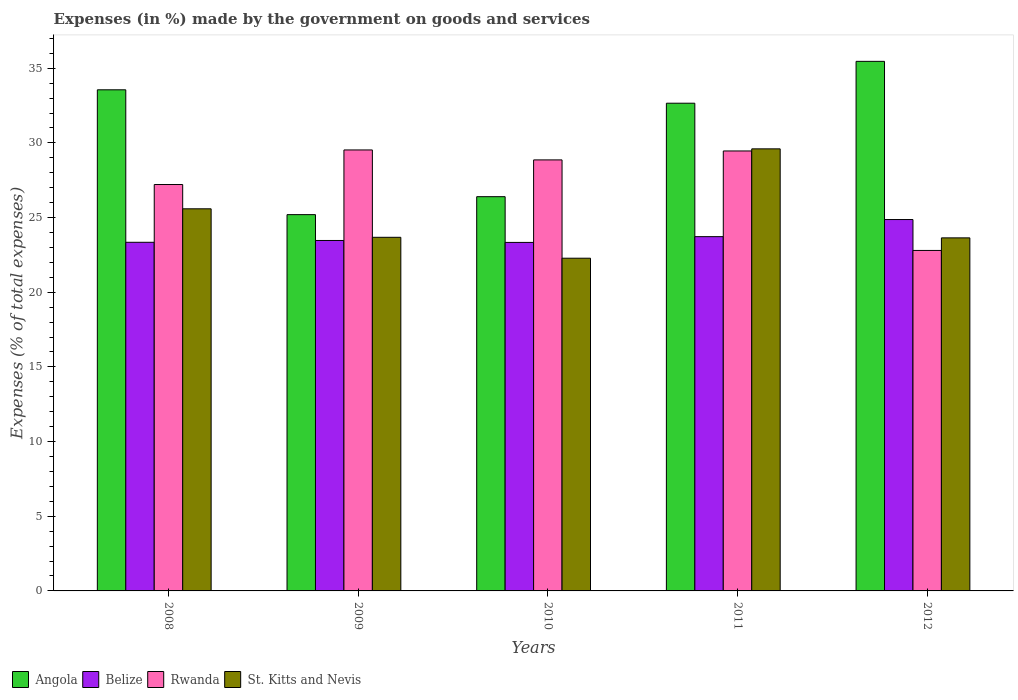How many different coloured bars are there?
Your response must be concise. 4. Are the number of bars on each tick of the X-axis equal?
Ensure brevity in your answer.  Yes. What is the label of the 1st group of bars from the left?
Ensure brevity in your answer.  2008. In how many cases, is the number of bars for a given year not equal to the number of legend labels?
Give a very brief answer. 0. What is the percentage of expenses made by the government on goods and services in Rwanda in 2010?
Your response must be concise. 28.86. Across all years, what is the maximum percentage of expenses made by the government on goods and services in Angola?
Your answer should be very brief. 35.46. Across all years, what is the minimum percentage of expenses made by the government on goods and services in Rwanda?
Offer a terse response. 22.8. What is the total percentage of expenses made by the government on goods and services in Rwanda in the graph?
Your answer should be compact. 137.86. What is the difference between the percentage of expenses made by the government on goods and services in St. Kitts and Nevis in 2009 and that in 2011?
Your response must be concise. -5.92. What is the difference between the percentage of expenses made by the government on goods and services in Angola in 2008 and the percentage of expenses made by the government on goods and services in Belize in 2012?
Your response must be concise. 8.69. What is the average percentage of expenses made by the government on goods and services in Rwanda per year?
Make the answer very short. 27.57. In the year 2010, what is the difference between the percentage of expenses made by the government on goods and services in Rwanda and percentage of expenses made by the government on goods and services in Angola?
Give a very brief answer. 2.46. What is the ratio of the percentage of expenses made by the government on goods and services in Angola in 2011 to that in 2012?
Ensure brevity in your answer.  0.92. Is the difference between the percentage of expenses made by the government on goods and services in Rwanda in 2011 and 2012 greater than the difference between the percentage of expenses made by the government on goods and services in Angola in 2011 and 2012?
Make the answer very short. Yes. What is the difference between the highest and the second highest percentage of expenses made by the government on goods and services in Belize?
Provide a succinct answer. 1.15. What is the difference between the highest and the lowest percentage of expenses made by the government on goods and services in St. Kitts and Nevis?
Provide a short and direct response. 7.32. Is the sum of the percentage of expenses made by the government on goods and services in Rwanda in 2008 and 2012 greater than the maximum percentage of expenses made by the government on goods and services in Belize across all years?
Give a very brief answer. Yes. Is it the case that in every year, the sum of the percentage of expenses made by the government on goods and services in Belize and percentage of expenses made by the government on goods and services in Rwanda is greater than the sum of percentage of expenses made by the government on goods and services in St. Kitts and Nevis and percentage of expenses made by the government on goods and services in Angola?
Keep it short and to the point. No. What does the 3rd bar from the left in 2012 represents?
Make the answer very short. Rwanda. What does the 2nd bar from the right in 2008 represents?
Make the answer very short. Rwanda. Is it the case that in every year, the sum of the percentage of expenses made by the government on goods and services in Angola and percentage of expenses made by the government on goods and services in Rwanda is greater than the percentage of expenses made by the government on goods and services in Belize?
Offer a terse response. Yes. Are all the bars in the graph horizontal?
Give a very brief answer. No. Where does the legend appear in the graph?
Give a very brief answer. Bottom left. How are the legend labels stacked?
Your answer should be very brief. Horizontal. What is the title of the graph?
Offer a very short reply. Expenses (in %) made by the government on goods and services. Does "Bosnia and Herzegovina" appear as one of the legend labels in the graph?
Provide a succinct answer. No. What is the label or title of the X-axis?
Provide a succinct answer. Years. What is the label or title of the Y-axis?
Make the answer very short. Expenses (% of total expenses). What is the Expenses (% of total expenses) in Angola in 2008?
Offer a very short reply. 33.56. What is the Expenses (% of total expenses) in Belize in 2008?
Your answer should be compact. 23.35. What is the Expenses (% of total expenses) of Rwanda in 2008?
Your response must be concise. 27.21. What is the Expenses (% of total expenses) in St. Kitts and Nevis in 2008?
Make the answer very short. 25.59. What is the Expenses (% of total expenses) in Angola in 2009?
Your response must be concise. 25.2. What is the Expenses (% of total expenses) of Belize in 2009?
Offer a terse response. 23.47. What is the Expenses (% of total expenses) in Rwanda in 2009?
Your response must be concise. 29.53. What is the Expenses (% of total expenses) in St. Kitts and Nevis in 2009?
Your answer should be very brief. 23.68. What is the Expenses (% of total expenses) of Angola in 2010?
Provide a short and direct response. 26.4. What is the Expenses (% of total expenses) in Belize in 2010?
Offer a very short reply. 23.34. What is the Expenses (% of total expenses) of Rwanda in 2010?
Offer a very short reply. 28.86. What is the Expenses (% of total expenses) in St. Kitts and Nevis in 2010?
Provide a succinct answer. 22.28. What is the Expenses (% of total expenses) in Angola in 2011?
Provide a succinct answer. 32.66. What is the Expenses (% of total expenses) of Belize in 2011?
Your response must be concise. 23.72. What is the Expenses (% of total expenses) in Rwanda in 2011?
Keep it short and to the point. 29.46. What is the Expenses (% of total expenses) in St. Kitts and Nevis in 2011?
Keep it short and to the point. 29.6. What is the Expenses (% of total expenses) in Angola in 2012?
Your response must be concise. 35.46. What is the Expenses (% of total expenses) of Belize in 2012?
Offer a very short reply. 24.87. What is the Expenses (% of total expenses) of Rwanda in 2012?
Offer a terse response. 22.8. What is the Expenses (% of total expenses) in St. Kitts and Nevis in 2012?
Make the answer very short. 23.64. Across all years, what is the maximum Expenses (% of total expenses) of Angola?
Provide a succinct answer. 35.46. Across all years, what is the maximum Expenses (% of total expenses) in Belize?
Your answer should be compact. 24.87. Across all years, what is the maximum Expenses (% of total expenses) of Rwanda?
Make the answer very short. 29.53. Across all years, what is the maximum Expenses (% of total expenses) in St. Kitts and Nevis?
Make the answer very short. 29.6. Across all years, what is the minimum Expenses (% of total expenses) of Angola?
Ensure brevity in your answer.  25.2. Across all years, what is the minimum Expenses (% of total expenses) of Belize?
Keep it short and to the point. 23.34. Across all years, what is the minimum Expenses (% of total expenses) of Rwanda?
Offer a very short reply. 22.8. Across all years, what is the minimum Expenses (% of total expenses) of St. Kitts and Nevis?
Keep it short and to the point. 22.28. What is the total Expenses (% of total expenses) of Angola in the graph?
Ensure brevity in your answer.  153.27. What is the total Expenses (% of total expenses) in Belize in the graph?
Ensure brevity in your answer.  118.74. What is the total Expenses (% of total expenses) in Rwanda in the graph?
Offer a terse response. 137.86. What is the total Expenses (% of total expenses) of St. Kitts and Nevis in the graph?
Ensure brevity in your answer.  124.79. What is the difference between the Expenses (% of total expenses) in Angola in 2008 and that in 2009?
Provide a short and direct response. 8.36. What is the difference between the Expenses (% of total expenses) in Belize in 2008 and that in 2009?
Provide a short and direct response. -0.12. What is the difference between the Expenses (% of total expenses) in Rwanda in 2008 and that in 2009?
Your response must be concise. -2.32. What is the difference between the Expenses (% of total expenses) of St. Kitts and Nevis in 2008 and that in 2009?
Ensure brevity in your answer.  1.91. What is the difference between the Expenses (% of total expenses) in Angola in 2008 and that in 2010?
Ensure brevity in your answer.  7.16. What is the difference between the Expenses (% of total expenses) in Belize in 2008 and that in 2010?
Provide a short and direct response. 0.01. What is the difference between the Expenses (% of total expenses) of Rwanda in 2008 and that in 2010?
Provide a succinct answer. -1.65. What is the difference between the Expenses (% of total expenses) in St. Kitts and Nevis in 2008 and that in 2010?
Your answer should be compact. 3.31. What is the difference between the Expenses (% of total expenses) of Angola in 2008 and that in 2011?
Keep it short and to the point. 0.9. What is the difference between the Expenses (% of total expenses) of Belize in 2008 and that in 2011?
Offer a very short reply. -0.38. What is the difference between the Expenses (% of total expenses) of Rwanda in 2008 and that in 2011?
Offer a very short reply. -2.25. What is the difference between the Expenses (% of total expenses) of St. Kitts and Nevis in 2008 and that in 2011?
Your answer should be very brief. -4.01. What is the difference between the Expenses (% of total expenses) in Angola in 2008 and that in 2012?
Provide a succinct answer. -1.91. What is the difference between the Expenses (% of total expenses) of Belize in 2008 and that in 2012?
Provide a short and direct response. -1.52. What is the difference between the Expenses (% of total expenses) of Rwanda in 2008 and that in 2012?
Provide a succinct answer. 4.41. What is the difference between the Expenses (% of total expenses) of St. Kitts and Nevis in 2008 and that in 2012?
Offer a very short reply. 1.95. What is the difference between the Expenses (% of total expenses) of Angola in 2009 and that in 2010?
Offer a very short reply. -1.2. What is the difference between the Expenses (% of total expenses) in Belize in 2009 and that in 2010?
Provide a short and direct response. 0.13. What is the difference between the Expenses (% of total expenses) of Rwanda in 2009 and that in 2010?
Provide a succinct answer. 0.67. What is the difference between the Expenses (% of total expenses) in St. Kitts and Nevis in 2009 and that in 2010?
Give a very brief answer. 1.4. What is the difference between the Expenses (% of total expenses) in Angola in 2009 and that in 2011?
Your answer should be compact. -7.46. What is the difference between the Expenses (% of total expenses) of Belize in 2009 and that in 2011?
Keep it short and to the point. -0.26. What is the difference between the Expenses (% of total expenses) in Rwanda in 2009 and that in 2011?
Offer a very short reply. 0.07. What is the difference between the Expenses (% of total expenses) in St. Kitts and Nevis in 2009 and that in 2011?
Provide a succinct answer. -5.92. What is the difference between the Expenses (% of total expenses) of Angola in 2009 and that in 2012?
Keep it short and to the point. -10.26. What is the difference between the Expenses (% of total expenses) of Belize in 2009 and that in 2012?
Give a very brief answer. -1.4. What is the difference between the Expenses (% of total expenses) in Rwanda in 2009 and that in 2012?
Your answer should be compact. 6.73. What is the difference between the Expenses (% of total expenses) in St. Kitts and Nevis in 2009 and that in 2012?
Offer a very short reply. 0.04. What is the difference between the Expenses (% of total expenses) in Angola in 2010 and that in 2011?
Ensure brevity in your answer.  -6.26. What is the difference between the Expenses (% of total expenses) in Belize in 2010 and that in 2011?
Offer a very short reply. -0.39. What is the difference between the Expenses (% of total expenses) in Rwanda in 2010 and that in 2011?
Give a very brief answer. -0.6. What is the difference between the Expenses (% of total expenses) of St. Kitts and Nevis in 2010 and that in 2011?
Make the answer very short. -7.32. What is the difference between the Expenses (% of total expenses) of Angola in 2010 and that in 2012?
Offer a terse response. -9.06. What is the difference between the Expenses (% of total expenses) in Belize in 2010 and that in 2012?
Your response must be concise. -1.53. What is the difference between the Expenses (% of total expenses) in Rwanda in 2010 and that in 2012?
Your response must be concise. 6.06. What is the difference between the Expenses (% of total expenses) in St. Kitts and Nevis in 2010 and that in 2012?
Your answer should be very brief. -1.36. What is the difference between the Expenses (% of total expenses) in Angola in 2011 and that in 2012?
Make the answer very short. -2.8. What is the difference between the Expenses (% of total expenses) of Belize in 2011 and that in 2012?
Provide a short and direct response. -1.15. What is the difference between the Expenses (% of total expenses) in Rwanda in 2011 and that in 2012?
Give a very brief answer. 6.66. What is the difference between the Expenses (% of total expenses) in St. Kitts and Nevis in 2011 and that in 2012?
Keep it short and to the point. 5.96. What is the difference between the Expenses (% of total expenses) in Angola in 2008 and the Expenses (% of total expenses) in Belize in 2009?
Offer a terse response. 10.09. What is the difference between the Expenses (% of total expenses) in Angola in 2008 and the Expenses (% of total expenses) in Rwanda in 2009?
Ensure brevity in your answer.  4.03. What is the difference between the Expenses (% of total expenses) of Angola in 2008 and the Expenses (% of total expenses) of St. Kitts and Nevis in 2009?
Give a very brief answer. 9.88. What is the difference between the Expenses (% of total expenses) of Belize in 2008 and the Expenses (% of total expenses) of Rwanda in 2009?
Ensure brevity in your answer.  -6.18. What is the difference between the Expenses (% of total expenses) of Belize in 2008 and the Expenses (% of total expenses) of St. Kitts and Nevis in 2009?
Offer a terse response. -0.33. What is the difference between the Expenses (% of total expenses) in Rwanda in 2008 and the Expenses (% of total expenses) in St. Kitts and Nevis in 2009?
Your response must be concise. 3.53. What is the difference between the Expenses (% of total expenses) of Angola in 2008 and the Expenses (% of total expenses) of Belize in 2010?
Ensure brevity in your answer.  10.22. What is the difference between the Expenses (% of total expenses) in Angola in 2008 and the Expenses (% of total expenses) in Rwanda in 2010?
Your answer should be compact. 4.69. What is the difference between the Expenses (% of total expenses) of Angola in 2008 and the Expenses (% of total expenses) of St. Kitts and Nevis in 2010?
Ensure brevity in your answer.  11.28. What is the difference between the Expenses (% of total expenses) in Belize in 2008 and the Expenses (% of total expenses) in Rwanda in 2010?
Ensure brevity in your answer.  -5.52. What is the difference between the Expenses (% of total expenses) of Belize in 2008 and the Expenses (% of total expenses) of St. Kitts and Nevis in 2010?
Your response must be concise. 1.07. What is the difference between the Expenses (% of total expenses) of Rwanda in 2008 and the Expenses (% of total expenses) of St. Kitts and Nevis in 2010?
Keep it short and to the point. 4.93. What is the difference between the Expenses (% of total expenses) of Angola in 2008 and the Expenses (% of total expenses) of Belize in 2011?
Offer a very short reply. 9.83. What is the difference between the Expenses (% of total expenses) in Angola in 2008 and the Expenses (% of total expenses) in Rwanda in 2011?
Offer a very short reply. 4.09. What is the difference between the Expenses (% of total expenses) in Angola in 2008 and the Expenses (% of total expenses) in St. Kitts and Nevis in 2011?
Ensure brevity in your answer.  3.95. What is the difference between the Expenses (% of total expenses) of Belize in 2008 and the Expenses (% of total expenses) of Rwanda in 2011?
Offer a very short reply. -6.12. What is the difference between the Expenses (% of total expenses) of Belize in 2008 and the Expenses (% of total expenses) of St. Kitts and Nevis in 2011?
Your answer should be compact. -6.26. What is the difference between the Expenses (% of total expenses) of Rwanda in 2008 and the Expenses (% of total expenses) of St. Kitts and Nevis in 2011?
Make the answer very short. -2.39. What is the difference between the Expenses (% of total expenses) in Angola in 2008 and the Expenses (% of total expenses) in Belize in 2012?
Your response must be concise. 8.69. What is the difference between the Expenses (% of total expenses) in Angola in 2008 and the Expenses (% of total expenses) in Rwanda in 2012?
Your answer should be compact. 10.76. What is the difference between the Expenses (% of total expenses) in Angola in 2008 and the Expenses (% of total expenses) in St. Kitts and Nevis in 2012?
Your answer should be compact. 9.91. What is the difference between the Expenses (% of total expenses) in Belize in 2008 and the Expenses (% of total expenses) in Rwanda in 2012?
Offer a very short reply. 0.55. What is the difference between the Expenses (% of total expenses) of Belize in 2008 and the Expenses (% of total expenses) of St. Kitts and Nevis in 2012?
Your answer should be very brief. -0.3. What is the difference between the Expenses (% of total expenses) in Rwanda in 2008 and the Expenses (% of total expenses) in St. Kitts and Nevis in 2012?
Your answer should be very brief. 3.57. What is the difference between the Expenses (% of total expenses) of Angola in 2009 and the Expenses (% of total expenses) of Belize in 2010?
Keep it short and to the point. 1.86. What is the difference between the Expenses (% of total expenses) in Angola in 2009 and the Expenses (% of total expenses) in Rwanda in 2010?
Your response must be concise. -3.67. What is the difference between the Expenses (% of total expenses) of Angola in 2009 and the Expenses (% of total expenses) of St. Kitts and Nevis in 2010?
Provide a succinct answer. 2.92. What is the difference between the Expenses (% of total expenses) in Belize in 2009 and the Expenses (% of total expenses) in Rwanda in 2010?
Your answer should be compact. -5.4. What is the difference between the Expenses (% of total expenses) of Belize in 2009 and the Expenses (% of total expenses) of St. Kitts and Nevis in 2010?
Make the answer very short. 1.19. What is the difference between the Expenses (% of total expenses) of Rwanda in 2009 and the Expenses (% of total expenses) of St. Kitts and Nevis in 2010?
Give a very brief answer. 7.25. What is the difference between the Expenses (% of total expenses) of Angola in 2009 and the Expenses (% of total expenses) of Belize in 2011?
Give a very brief answer. 1.47. What is the difference between the Expenses (% of total expenses) in Angola in 2009 and the Expenses (% of total expenses) in Rwanda in 2011?
Your answer should be compact. -4.26. What is the difference between the Expenses (% of total expenses) in Angola in 2009 and the Expenses (% of total expenses) in St. Kitts and Nevis in 2011?
Ensure brevity in your answer.  -4.41. What is the difference between the Expenses (% of total expenses) in Belize in 2009 and the Expenses (% of total expenses) in Rwanda in 2011?
Keep it short and to the point. -5.99. What is the difference between the Expenses (% of total expenses) in Belize in 2009 and the Expenses (% of total expenses) in St. Kitts and Nevis in 2011?
Make the answer very short. -6.13. What is the difference between the Expenses (% of total expenses) of Rwanda in 2009 and the Expenses (% of total expenses) of St. Kitts and Nevis in 2011?
Make the answer very short. -0.07. What is the difference between the Expenses (% of total expenses) of Angola in 2009 and the Expenses (% of total expenses) of Belize in 2012?
Ensure brevity in your answer.  0.33. What is the difference between the Expenses (% of total expenses) in Angola in 2009 and the Expenses (% of total expenses) in Rwanda in 2012?
Your answer should be very brief. 2.4. What is the difference between the Expenses (% of total expenses) in Angola in 2009 and the Expenses (% of total expenses) in St. Kitts and Nevis in 2012?
Ensure brevity in your answer.  1.56. What is the difference between the Expenses (% of total expenses) of Belize in 2009 and the Expenses (% of total expenses) of Rwanda in 2012?
Your answer should be very brief. 0.67. What is the difference between the Expenses (% of total expenses) in Belize in 2009 and the Expenses (% of total expenses) in St. Kitts and Nevis in 2012?
Ensure brevity in your answer.  -0.17. What is the difference between the Expenses (% of total expenses) in Rwanda in 2009 and the Expenses (% of total expenses) in St. Kitts and Nevis in 2012?
Offer a very short reply. 5.89. What is the difference between the Expenses (% of total expenses) of Angola in 2010 and the Expenses (% of total expenses) of Belize in 2011?
Your answer should be compact. 2.68. What is the difference between the Expenses (% of total expenses) in Angola in 2010 and the Expenses (% of total expenses) in Rwanda in 2011?
Offer a terse response. -3.06. What is the difference between the Expenses (% of total expenses) in Angola in 2010 and the Expenses (% of total expenses) in St. Kitts and Nevis in 2011?
Your response must be concise. -3.2. What is the difference between the Expenses (% of total expenses) of Belize in 2010 and the Expenses (% of total expenses) of Rwanda in 2011?
Make the answer very short. -6.12. What is the difference between the Expenses (% of total expenses) of Belize in 2010 and the Expenses (% of total expenses) of St. Kitts and Nevis in 2011?
Your response must be concise. -6.27. What is the difference between the Expenses (% of total expenses) of Rwanda in 2010 and the Expenses (% of total expenses) of St. Kitts and Nevis in 2011?
Give a very brief answer. -0.74. What is the difference between the Expenses (% of total expenses) in Angola in 2010 and the Expenses (% of total expenses) in Belize in 2012?
Offer a terse response. 1.53. What is the difference between the Expenses (% of total expenses) in Angola in 2010 and the Expenses (% of total expenses) in Rwanda in 2012?
Offer a terse response. 3.6. What is the difference between the Expenses (% of total expenses) of Angola in 2010 and the Expenses (% of total expenses) of St. Kitts and Nevis in 2012?
Your response must be concise. 2.76. What is the difference between the Expenses (% of total expenses) of Belize in 2010 and the Expenses (% of total expenses) of Rwanda in 2012?
Offer a terse response. 0.54. What is the difference between the Expenses (% of total expenses) of Belize in 2010 and the Expenses (% of total expenses) of St. Kitts and Nevis in 2012?
Your answer should be very brief. -0.3. What is the difference between the Expenses (% of total expenses) in Rwanda in 2010 and the Expenses (% of total expenses) in St. Kitts and Nevis in 2012?
Your response must be concise. 5.22. What is the difference between the Expenses (% of total expenses) in Angola in 2011 and the Expenses (% of total expenses) in Belize in 2012?
Give a very brief answer. 7.79. What is the difference between the Expenses (% of total expenses) in Angola in 2011 and the Expenses (% of total expenses) in Rwanda in 2012?
Keep it short and to the point. 9.86. What is the difference between the Expenses (% of total expenses) in Angola in 2011 and the Expenses (% of total expenses) in St. Kitts and Nevis in 2012?
Your response must be concise. 9.02. What is the difference between the Expenses (% of total expenses) of Belize in 2011 and the Expenses (% of total expenses) of Rwanda in 2012?
Offer a very short reply. 0.92. What is the difference between the Expenses (% of total expenses) in Belize in 2011 and the Expenses (% of total expenses) in St. Kitts and Nevis in 2012?
Provide a short and direct response. 0.08. What is the difference between the Expenses (% of total expenses) in Rwanda in 2011 and the Expenses (% of total expenses) in St. Kitts and Nevis in 2012?
Give a very brief answer. 5.82. What is the average Expenses (% of total expenses) of Angola per year?
Offer a very short reply. 30.65. What is the average Expenses (% of total expenses) of Belize per year?
Your response must be concise. 23.75. What is the average Expenses (% of total expenses) in Rwanda per year?
Offer a terse response. 27.57. What is the average Expenses (% of total expenses) in St. Kitts and Nevis per year?
Offer a very short reply. 24.96. In the year 2008, what is the difference between the Expenses (% of total expenses) in Angola and Expenses (% of total expenses) in Belize?
Your answer should be very brief. 10.21. In the year 2008, what is the difference between the Expenses (% of total expenses) in Angola and Expenses (% of total expenses) in Rwanda?
Offer a terse response. 6.34. In the year 2008, what is the difference between the Expenses (% of total expenses) in Angola and Expenses (% of total expenses) in St. Kitts and Nevis?
Your response must be concise. 7.97. In the year 2008, what is the difference between the Expenses (% of total expenses) of Belize and Expenses (% of total expenses) of Rwanda?
Offer a terse response. -3.87. In the year 2008, what is the difference between the Expenses (% of total expenses) of Belize and Expenses (% of total expenses) of St. Kitts and Nevis?
Keep it short and to the point. -2.24. In the year 2008, what is the difference between the Expenses (% of total expenses) of Rwanda and Expenses (% of total expenses) of St. Kitts and Nevis?
Offer a very short reply. 1.63. In the year 2009, what is the difference between the Expenses (% of total expenses) in Angola and Expenses (% of total expenses) in Belize?
Your response must be concise. 1.73. In the year 2009, what is the difference between the Expenses (% of total expenses) in Angola and Expenses (% of total expenses) in Rwanda?
Provide a short and direct response. -4.33. In the year 2009, what is the difference between the Expenses (% of total expenses) of Angola and Expenses (% of total expenses) of St. Kitts and Nevis?
Ensure brevity in your answer.  1.52. In the year 2009, what is the difference between the Expenses (% of total expenses) in Belize and Expenses (% of total expenses) in Rwanda?
Keep it short and to the point. -6.06. In the year 2009, what is the difference between the Expenses (% of total expenses) in Belize and Expenses (% of total expenses) in St. Kitts and Nevis?
Your response must be concise. -0.21. In the year 2009, what is the difference between the Expenses (% of total expenses) in Rwanda and Expenses (% of total expenses) in St. Kitts and Nevis?
Your answer should be very brief. 5.85. In the year 2010, what is the difference between the Expenses (% of total expenses) of Angola and Expenses (% of total expenses) of Belize?
Offer a terse response. 3.06. In the year 2010, what is the difference between the Expenses (% of total expenses) in Angola and Expenses (% of total expenses) in Rwanda?
Provide a short and direct response. -2.46. In the year 2010, what is the difference between the Expenses (% of total expenses) in Angola and Expenses (% of total expenses) in St. Kitts and Nevis?
Offer a terse response. 4.12. In the year 2010, what is the difference between the Expenses (% of total expenses) of Belize and Expenses (% of total expenses) of Rwanda?
Offer a terse response. -5.53. In the year 2010, what is the difference between the Expenses (% of total expenses) in Belize and Expenses (% of total expenses) in St. Kitts and Nevis?
Offer a very short reply. 1.06. In the year 2010, what is the difference between the Expenses (% of total expenses) in Rwanda and Expenses (% of total expenses) in St. Kitts and Nevis?
Provide a short and direct response. 6.58. In the year 2011, what is the difference between the Expenses (% of total expenses) in Angola and Expenses (% of total expenses) in Belize?
Ensure brevity in your answer.  8.93. In the year 2011, what is the difference between the Expenses (% of total expenses) of Angola and Expenses (% of total expenses) of Rwanda?
Make the answer very short. 3.2. In the year 2011, what is the difference between the Expenses (% of total expenses) of Angola and Expenses (% of total expenses) of St. Kitts and Nevis?
Your response must be concise. 3.06. In the year 2011, what is the difference between the Expenses (% of total expenses) in Belize and Expenses (% of total expenses) in Rwanda?
Your answer should be very brief. -5.74. In the year 2011, what is the difference between the Expenses (% of total expenses) in Belize and Expenses (% of total expenses) in St. Kitts and Nevis?
Offer a terse response. -5.88. In the year 2011, what is the difference between the Expenses (% of total expenses) of Rwanda and Expenses (% of total expenses) of St. Kitts and Nevis?
Keep it short and to the point. -0.14. In the year 2012, what is the difference between the Expenses (% of total expenses) in Angola and Expenses (% of total expenses) in Belize?
Provide a short and direct response. 10.59. In the year 2012, what is the difference between the Expenses (% of total expenses) of Angola and Expenses (% of total expenses) of Rwanda?
Your response must be concise. 12.66. In the year 2012, what is the difference between the Expenses (% of total expenses) of Angola and Expenses (% of total expenses) of St. Kitts and Nevis?
Your response must be concise. 11.82. In the year 2012, what is the difference between the Expenses (% of total expenses) in Belize and Expenses (% of total expenses) in Rwanda?
Offer a very short reply. 2.07. In the year 2012, what is the difference between the Expenses (% of total expenses) in Belize and Expenses (% of total expenses) in St. Kitts and Nevis?
Offer a terse response. 1.23. In the year 2012, what is the difference between the Expenses (% of total expenses) in Rwanda and Expenses (% of total expenses) in St. Kitts and Nevis?
Make the answer very short. -0.84. What is the ratio of the Expenses (% of total expenses) in Angola in 2008 to that in 2009?
Give a very brief answer. 1.33. What is the ratio of the Expenses (% of total expenses) in Rwanda in 2008 to that in 2009?
Keep it short and to the point. 0.92. What is the ratio of the Expenses (% of total expenses) in St. Kitts and Nevis in 2008 to that in 2009?
Give a very brief answer. 1.08. What is the ratio of the Expenses (% of total expenses) in Angola in 2008 to that in 2010?
Provide a succinct answer. 1.27. What is the ratio of the Expenses (% of total expenses) of Rwanda in 2008 to that in 2010?
Offer a terse response. 0.94. What is the ratio of the Expenses (% of total expenses) in St. Kitts and Nevis in 2008 to that in 2010?
Your response must be concise. 1.15. What is the ratio of the Expenses (% of total expenses) of Angola in 2008 to that in 2011?
Provide a succinct answer. 1.03. What is the ratio of the Expenses (% of total expenses) of Belize in 2008 to that in 2011?
Ensure brevity in your answer.  0.98. What is the ratio of the Expenses (% of total expenses) in Rwanda in 2008 to that in 2011?
Make the answer very short. 0.92. What is the ratio of the Expenses (% of total expenses) of St. Kitts and Nevis in 2008 to that in 2011?
Your response must be concise. 0.86. What is the ratio of the Expenses (% of total expenses) in Angola in 2008 to that in 2012?
Your response must be concise. 0.95. What is the ratio of the Expenses (% of total expenses) of Belize in 2008 to that in 2012?
Provide a succinct answer. 0.94. What is the ratio of the Expenses (% of total expenses) in Rwanda in 2008 to that in 2012?
Ensure brevity in your answer.  1.19. What is the ratio of the Expenses (% of total expenses) of St. Kitts and Nevis in 2008 to that in 2012?
Offer a very short reply. 1.08. What is the ratio of the Expenses (% of total expenses) in Angola in 2009 to that in 2010?
Give a very brief answer. 0.95. What is the ratio of the Expenses (% of total expenses) of Belize in 2009 to that in 2010?
Provide a short and direct response. 1.01. What is the ratio of the Expenses (% of total expenses) in Rwanda in 2009 to that in 2010?
Give a very brief answer. 1.02. What is the ratio of the Expenses (% of total expenses) of St. Kitts and Nevis in 2009 to that in 2010?
Ensure brevity in your answer.  1.06. What is the ratio of the Expenses (% of total expenses) of Angola in 2009 to that in 2011?
Keep it short and to the point. 0.77. What is the ratio of the Expenses (% of total expenses) of St. Kitts and Nevis in 2009 to that in 2011?
Your response must be concise. 0.8. What is the ratio of the Expenses (% of total expenses) in Angola in 2009 to that in 2012?
Offer a terse response. 0.71. What is the ratio of the Expenses (% of total expenses) of Belize in 2009 to that in 2012?
Offer a terse response. 0.94. What is the ratio of the Expenses (% of total expenses) in Rwanda in 2009 to that in 2012?
Make the answer very short. 1.3. What is the ratio of the Expenses (% of total expenses) in Angola in 2010 to that in 2011?
Your answer should be very brief. 0.81. What is the ratio of the Expenses (% of total expenses) in Belize in 2010 to that in 2011?
Offer a terse response. 0.98. What is the ratio of the Expenses (% of total expenses) of Rwanda in 2010 to that in 2011?
Make the answer very short. 0.98. What is the ratio of the Expenses (% of total expenses) of St. Kitts and Nevis in 2010 to that in 2011?
Ensure brevity in your answer.  0.75. What is the ratio of the Expenses (% of total expenses) in Angola in 2010 to that in 2012?
Offer a terse response. 0.74. What is the ratio of the Expenses (% of total expenses) of Belize in 2010 to that in 2012?
Offer a very short reply. 0.94. What is the ratio of the Expenses (% of total expenses) of Rwanda in 2010 to that in 2012?
Keep it short and to the point. 1.27. What is the ratio of the Expenses (% of total expenses) in St. Kitts and Nevis in 2010 to that in 2012?
Your answer should be compact. 0.94. What is the ratio of the Expenses (% of total expenses) of Angola in 2011 to that in 2012?
Ensure brevity in your answer.  0.92. What is the ratio of the Expenses (% of total expenses) of Belize in 2011 to that in 2012?
Give a very brief answer. 0.95. What is the ratio of the Expenses (% of total expenses) of Rwanda in 2011 to that in 2012?
Ensure brevity in your answer.  1.29. What is the ratio of the Expenses (% of total expenses) in St. Kitts and Nevis in 2011 to that in 2012?
Keep it short and to the point. 1.25. What is the difference between the highest and the second highest Expenses (% of total expenses) in Angola?
Offer a very short reply. 1.91. What is the difference between the highest and the second highest Expenses (% of total expenses) of Belize?
Give a very brief answer. 1.15. What is the difference between the highest and the second highest Expenses (% of total expenses) of Rwanda?
Offer a terse response. 0.07. What is the difference between the highest and the second highest Expenses (% of total expenses) in St. Kitts and Nevis?
Provide a short and direct response. 4.01. What is the difference between the highest and the lowest Expenses (% of total expenses) of Angola?
Offer a very short reply. 10.26. What is the difference between the highest and the lowest Expenses (% of total expenses) in Belize?
Offer a terse response. 1.53. What is the difference between the highest and the lowest Expenses (% of total expenses) of Rwanda?
Provide a succinct answer. 6.73. What is the difference between the highest and the lowest Expenses (% of total expenses) in St. Kitts and Nevis?
Keep it short and to the point. 7.32. 